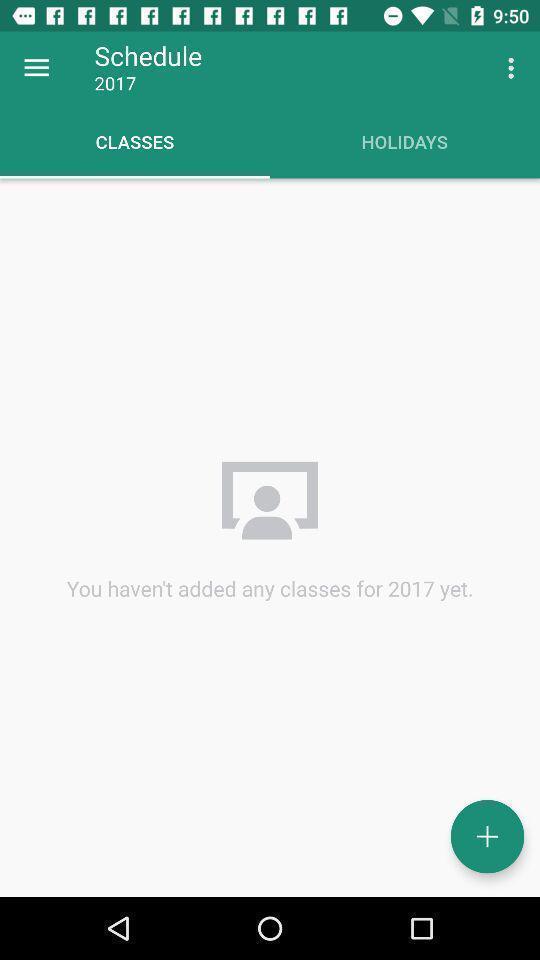Please provide a description for this image. Screen display classes page of a study app. 